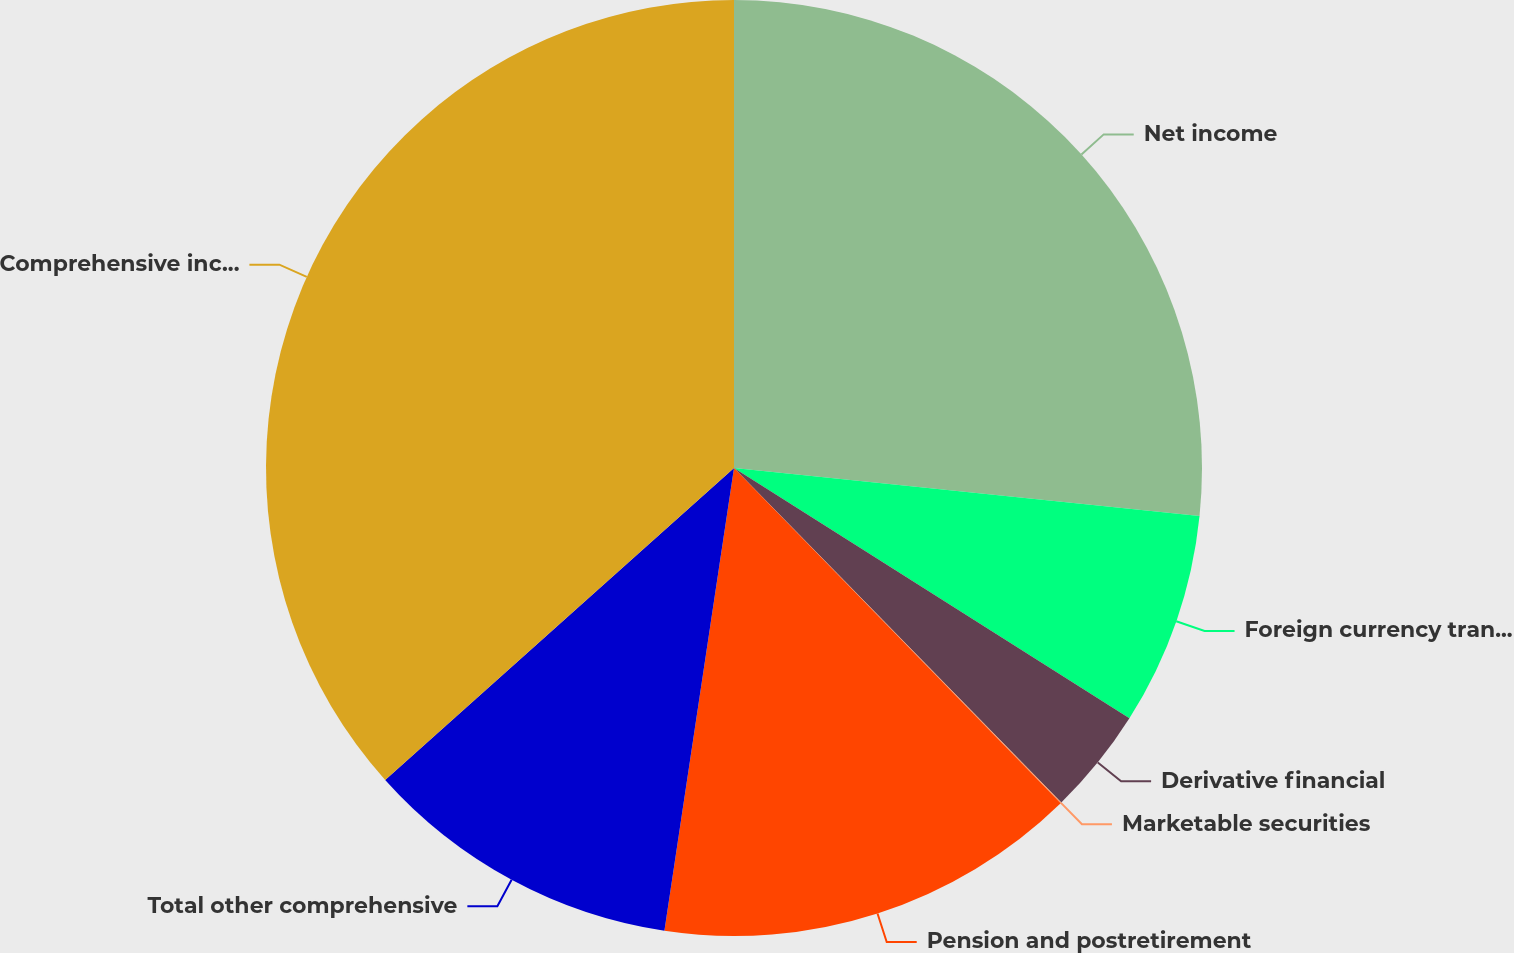Convert chart to OTSL. <chart><loc_0><loc_0><loc_500><loc_500><pie_chart><fcel>Net income<fcel>Foreign currency translation<fcel>Derivative financial<fcel>Marketable securities<fcel>Pension and postretirement<fcel>Total other comprehensive<fcel>Comprehensive income<nl><fcel>26.63%<fcel>7.35%<fcel>3.69%<fcel>0.03%<fcel>14.67%<fcel>11.01%<fcel>36.61%<nl></chart> 